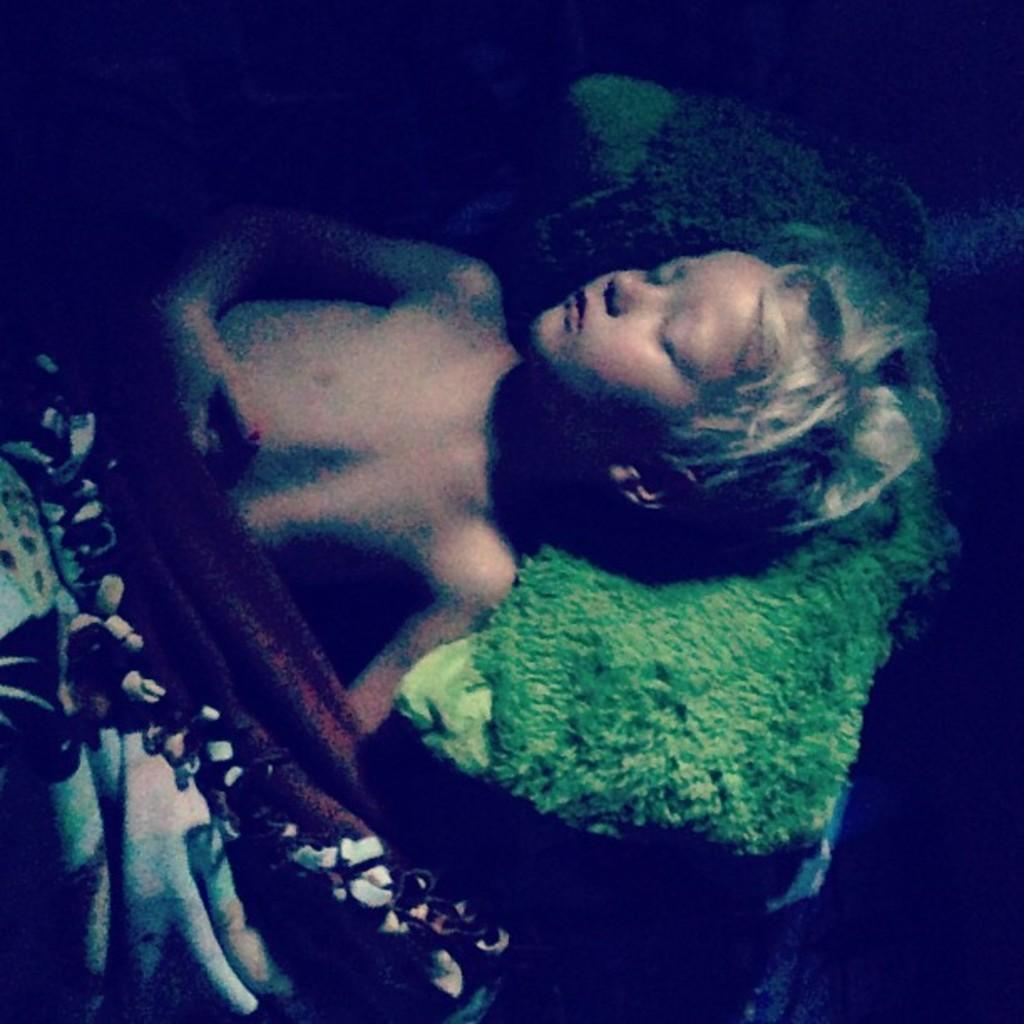Who or what can be seen in the image? There is a person in the image. What is the person doing in the image? The person is sleeping on a bed. What color is the pillow in the image? There is a green pillow in the image. What is covering the bed in the image? There is a bed sheet in the image. How many balls are visible in the image? There are no balls present in the image. What type of crate is being used as a nightstand in the image? There is no crate present in the image. 